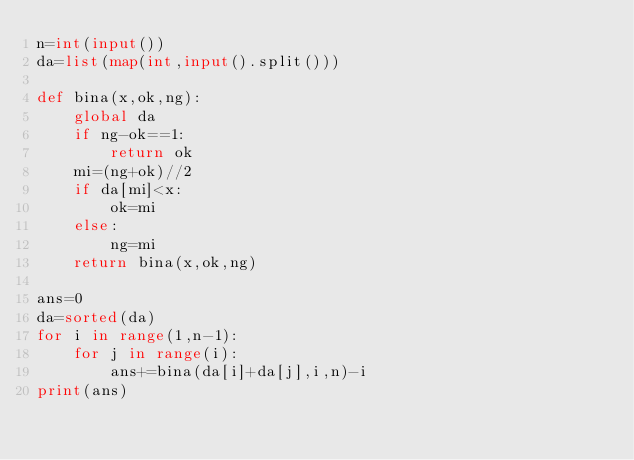Convert code to text. <code><loc_0><loc_0><loc_500><loc_500><_Python_>n=int(input())
da=list(map(int,input().split()))

def bina(x,ok,ng):
    global da
    if ng-ok==1:
        return ok
    mi=(ng+ok)//2
    if da[mi]<x:
        ok=mi
    else:
        ng=mi
    return bina(x,ok,ng)

ans=0
da=sorted(da)
for i in range(1,n-1):
    for j in range(i):
        ans+=bina(da[i]+da[j],i,n)-i
print(ans)</code> 